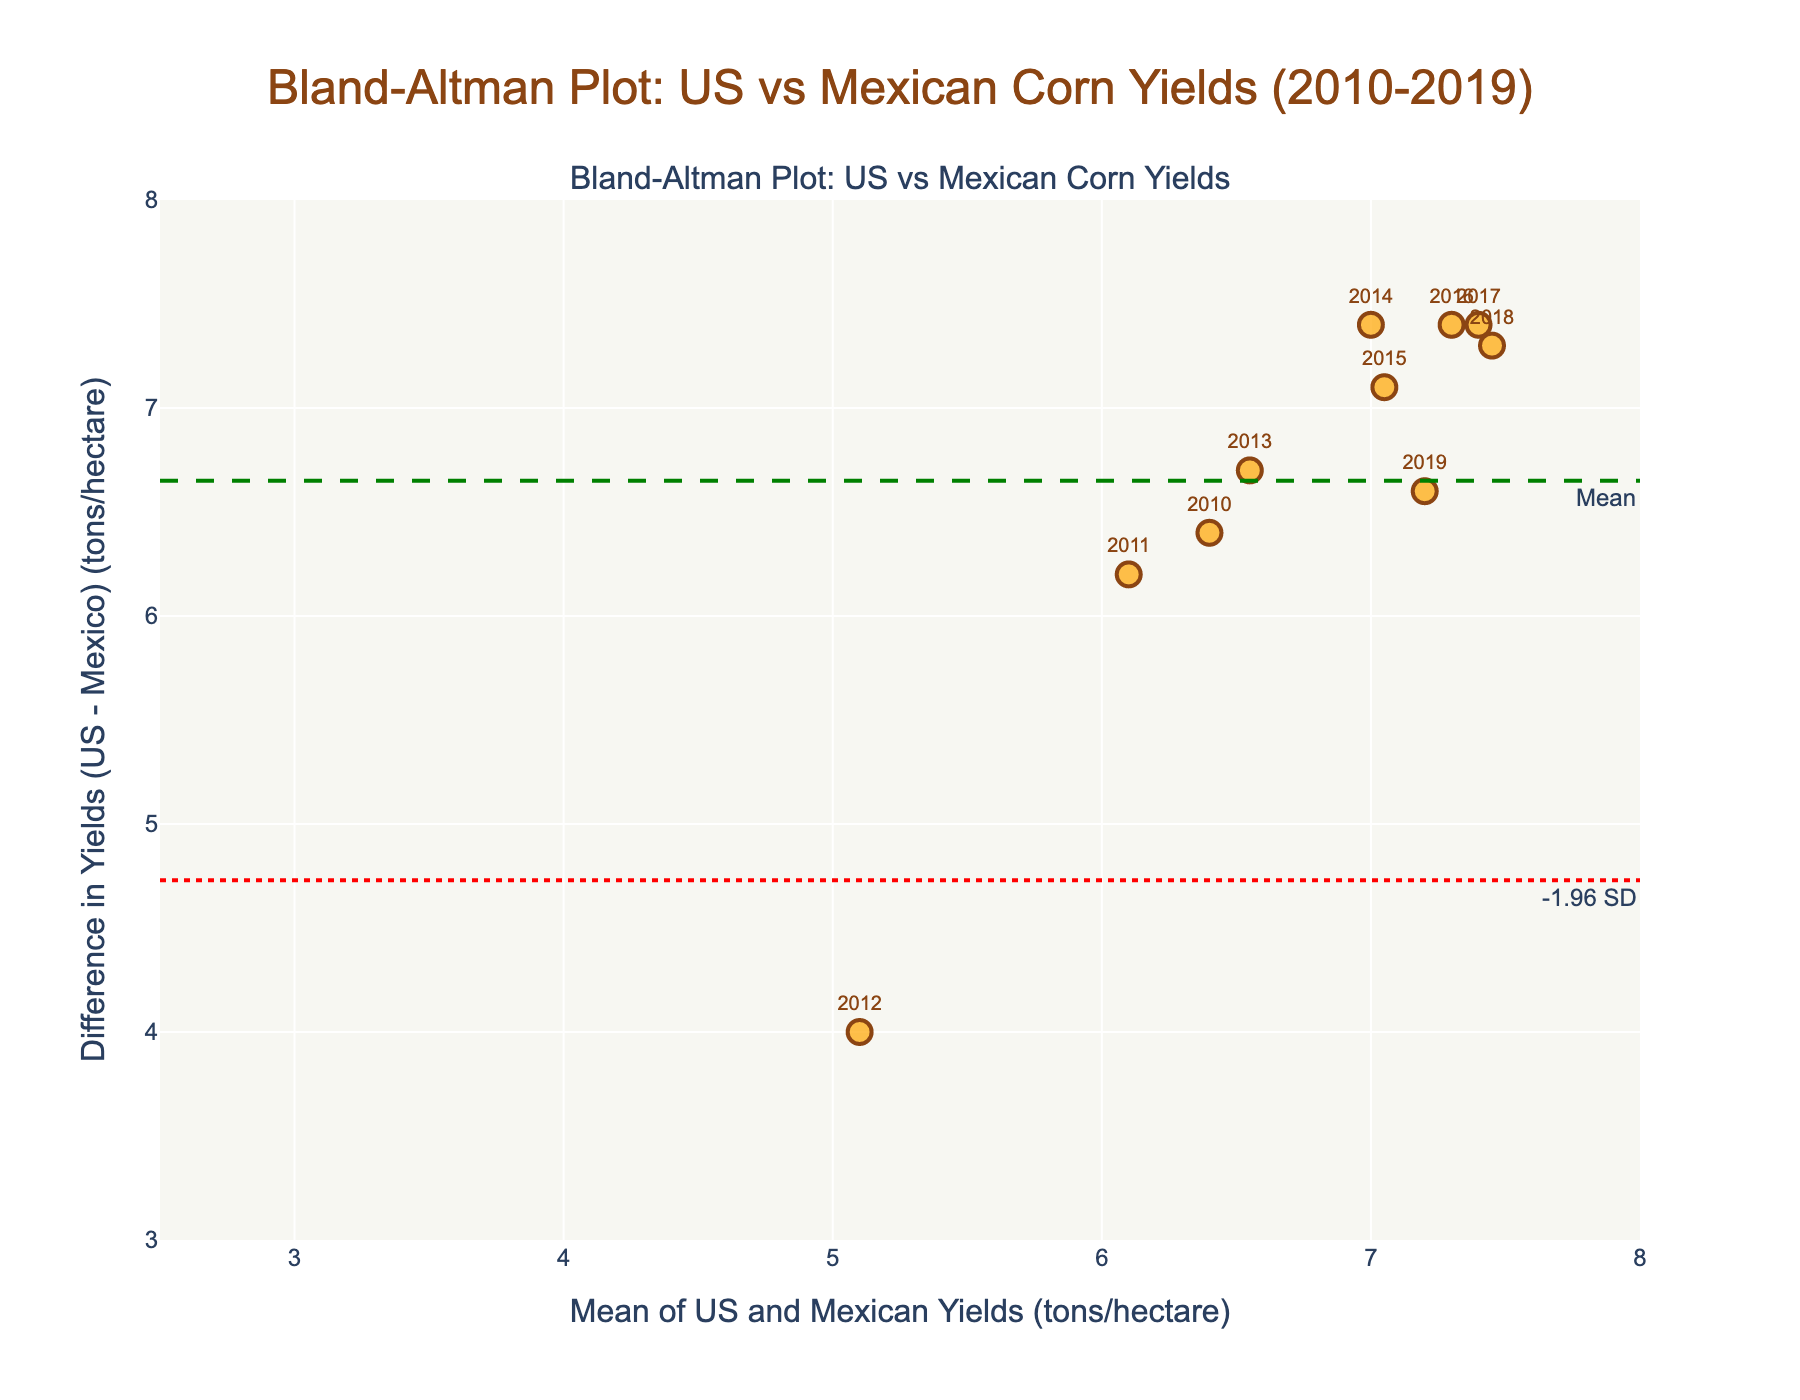What is the title of the Bland-Altman plot? The title is located at the top of the figure. It states "Bland-Altman Plot: US vs Mexican Corn Yields (2010-2019)".
Answer: Bland-Altman Plot: US vs Mexican Corn Yields (2010-2019) What is represented on the x-axis of the Bland-Altman plot? The label on the x-axis indicates that it shows the mean of the US and Mexican yields measured in tons per hectare.
Answer: Mean of US and Mexican Yields (tons/hectare) What is the range of the differences in yields (y-axis) shown in the plot? By observing the y-axis, the limits range roughly from 3 to 8 tons per hectare as indicated by the axis labels and gridlines.
Answer: 3 to 8 tons/hectare How many data points are shown in the Bland-Altman plot? The plot contains one data point per year from 2010 to 2019. This is directly visible by counting the number of points or years labeled.
Answer: 10 What is the mean difference in yields (US - Mexico) and how is it represented in the plot? The mean difference is represented by a green dashed line and can be identified by the annotation "Mean". It is a horizontal line that runs parallel to the x-axis.
Answer: A green dashed line What are the upper and lower limits of agreement, and how are they represented in the plot? The upper and lower limits of agreement are shown as red dotted lines marked "+1.96 SD" and "-1.96 SD", and these lines are parallel to the mean difference line.
Answer: Red dotted lines In which year did the Mexican yield show the least disparity compared to the US yield? By observing the data points close to the x-axis (difference close to zero), the least disparity is shown by the data point with the smallest difference. The year label near the smallest difference identifies the year.
Answer: 2012 Which year exhibits the highest positive disparity in differences in the plot? The year with the highest positive difference will have its data point at the topmost position on the y-axis. By checking the associated year label, we find the highest positive disparity.
Answer: 2017 Which two consecutive years show the biggest change in yield difference, and what is the value of that change? To find the biggest change, visually compare the heights of the differences (y-axis values) between consecutive years. Identify the years and calculate the change. For example, differences for 2012 (4) and 2013 (6.7) give the biggest change of 2.7.
Answer: 2012 to 2013, 2.7 tons/hectare 